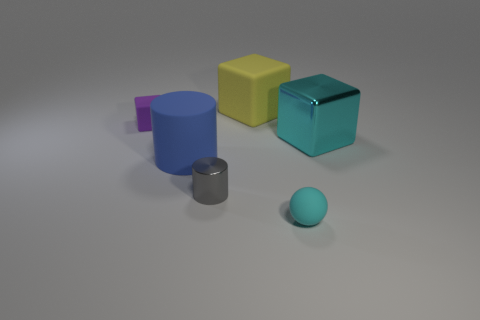What number of things are shiny objects or yellow rubber cubes behind the small rubber ball? In the image, there are two objects that match the description behind the small rubber ball: one yellow rubber cube and one shiny metal cylinder. Therefore, the total number of things that are either shiny objects or yellow rubber cubes behind the small rubber ball is two. 